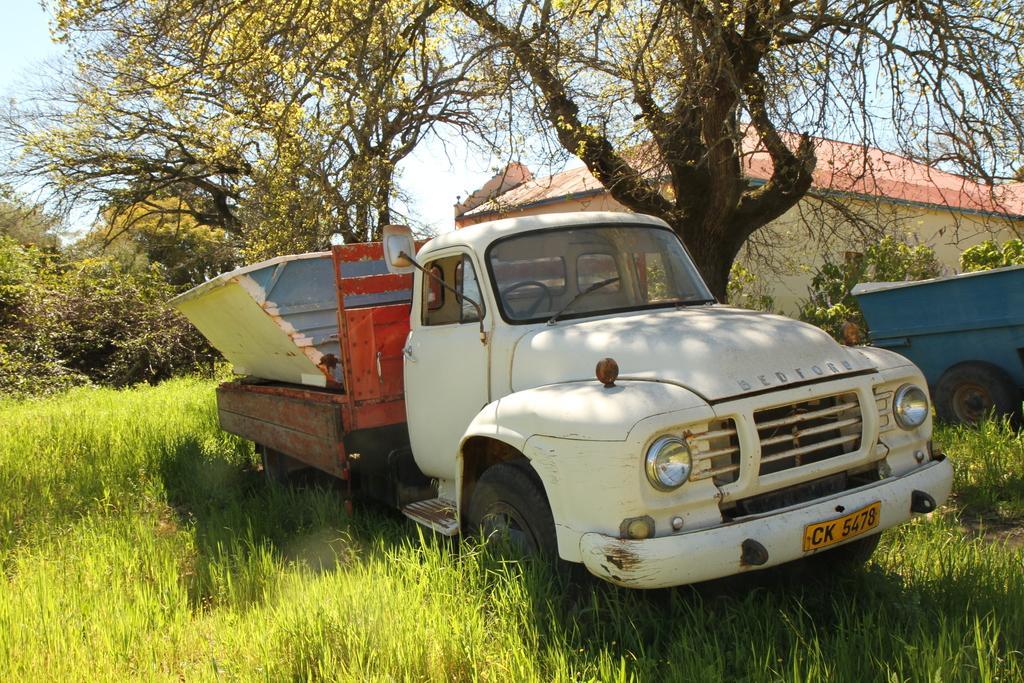In one or two sentences, can you explain what this image depicts? In this picture we can see a truck in the front, at the bottom there is grass, on the right side we can see another vehicle, there are trees and a house in the background, we can see the sky at the top of the picture. 